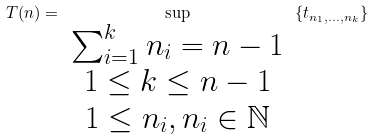Convert formula to latex. <formula><loc_0><loc_0><loc_500><loc_500>T ( n ) = \sup _ { \begin{array} { c } \sum _ { i = 1 } ^ { k } n _ { i } = n - 1 \\ 1 \leq k \leq n - 1 \\ 1 \leq n _ { i } , n _ { i } \in \mathbb { N } \end{array} } \left \{ t _ { n _ { 1 } , \dots , n _ { k } } \right \}</formula> 